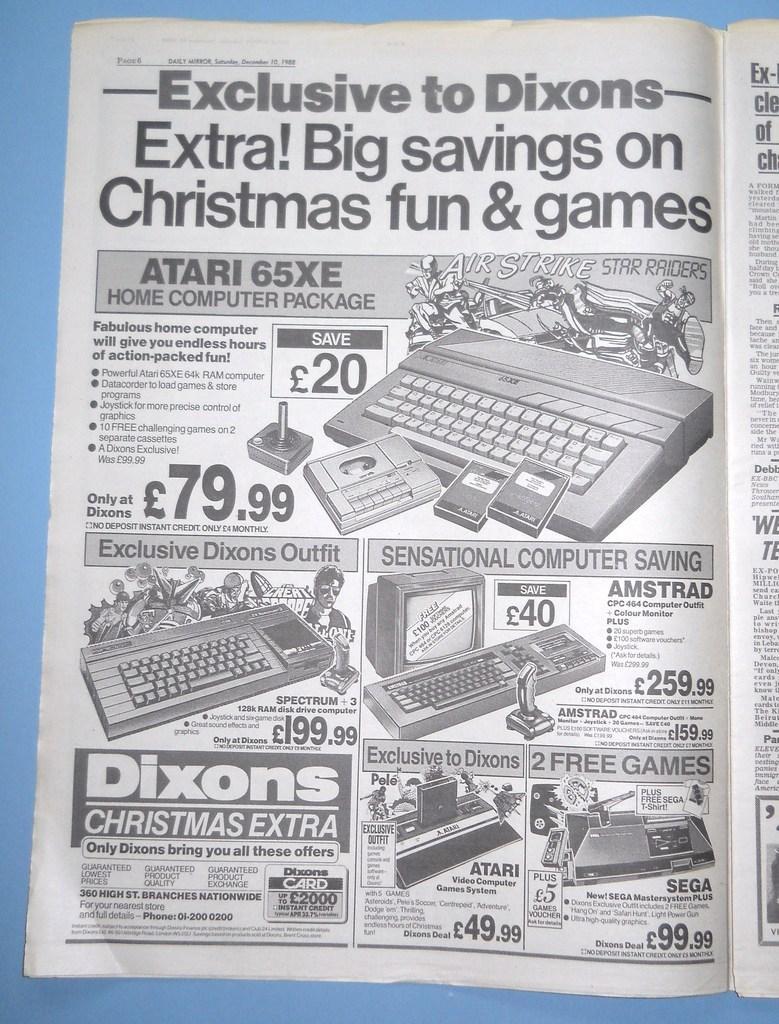Please provide a concise description of this image. In the center of the image we can see a book placed on the table. 